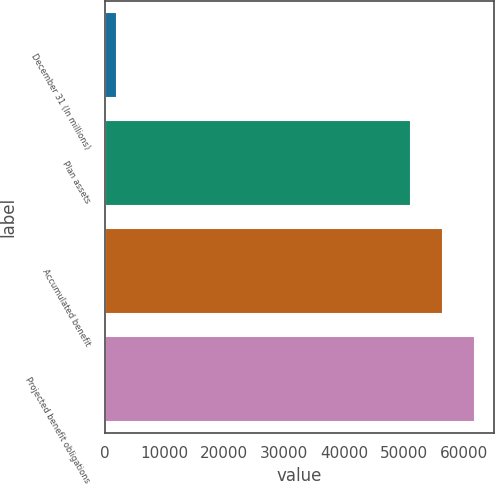<chart> <loc_0><loc_0><loc_500><loc_500><bar_chart><fcel>December 31 (In millions)<fcel>Plan assets<fcel>Accumulated benefit<fcel>Projected benefit obligations<nl><fcel>2010<fcel>51286<fcel>56635.2<fcel>61984.4<nl></chart> 